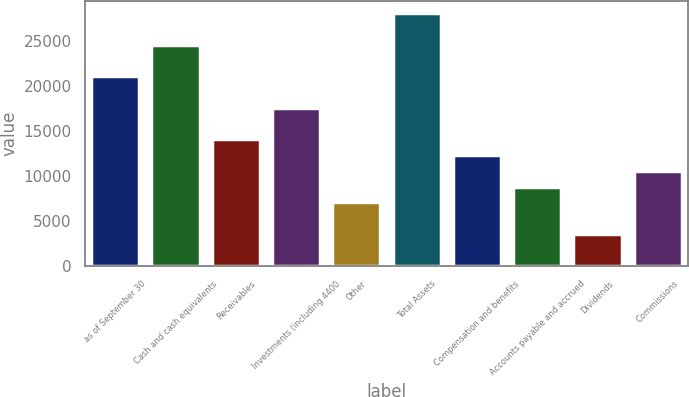<chart> <loc_0><loc_0><loc_500><loc_500><bar_chart><fcel>as of September 30<fcel>Cash and cash equivalents<fcel>Receivables<fcel>Investments (including 4400<fcel>Other<fcel>Total Assets<fcel>Compensation and benefits<fcel>Accounts payable and accrued<fcel>Dividends<fcel>Commissions<nl><fcel>21030.1<fcel>24526.2<fcel>14037.9<fcel>17534<fcel>7045.64<fcel>28022.4<fcel>12289.8<fcel>8793.7<fcel>3549.52<fcel>10541.8<nl></chart> 